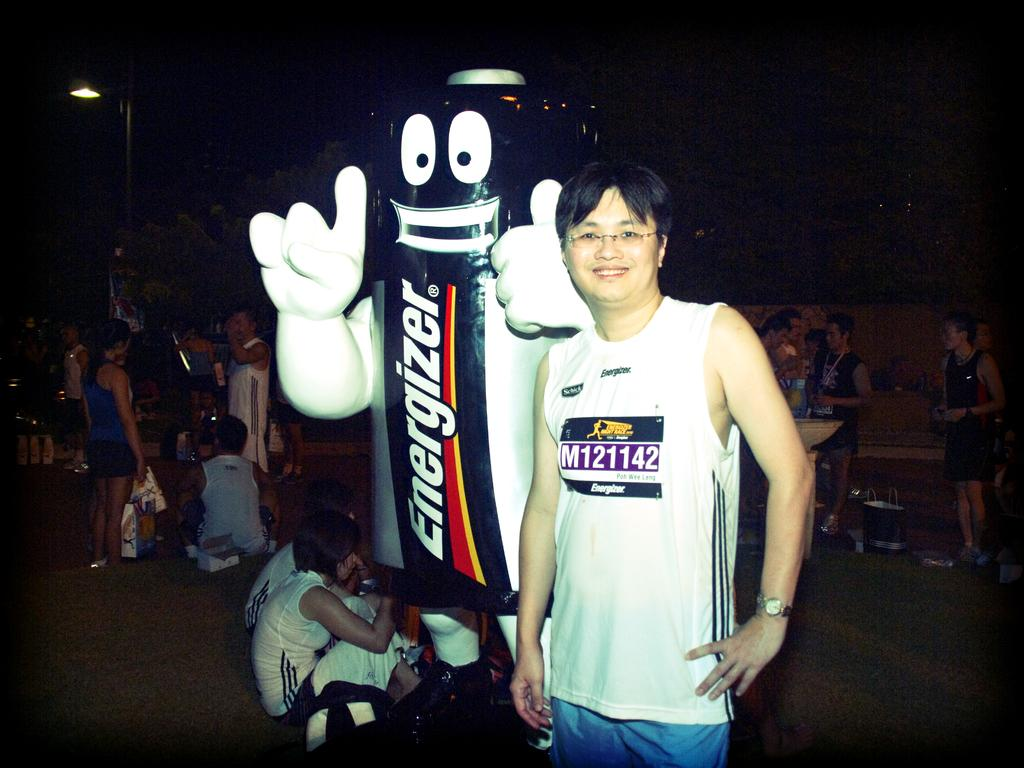<image>
Present a compact description of the photo's key features. a man stands smiling next to an Energizer battery mascot 